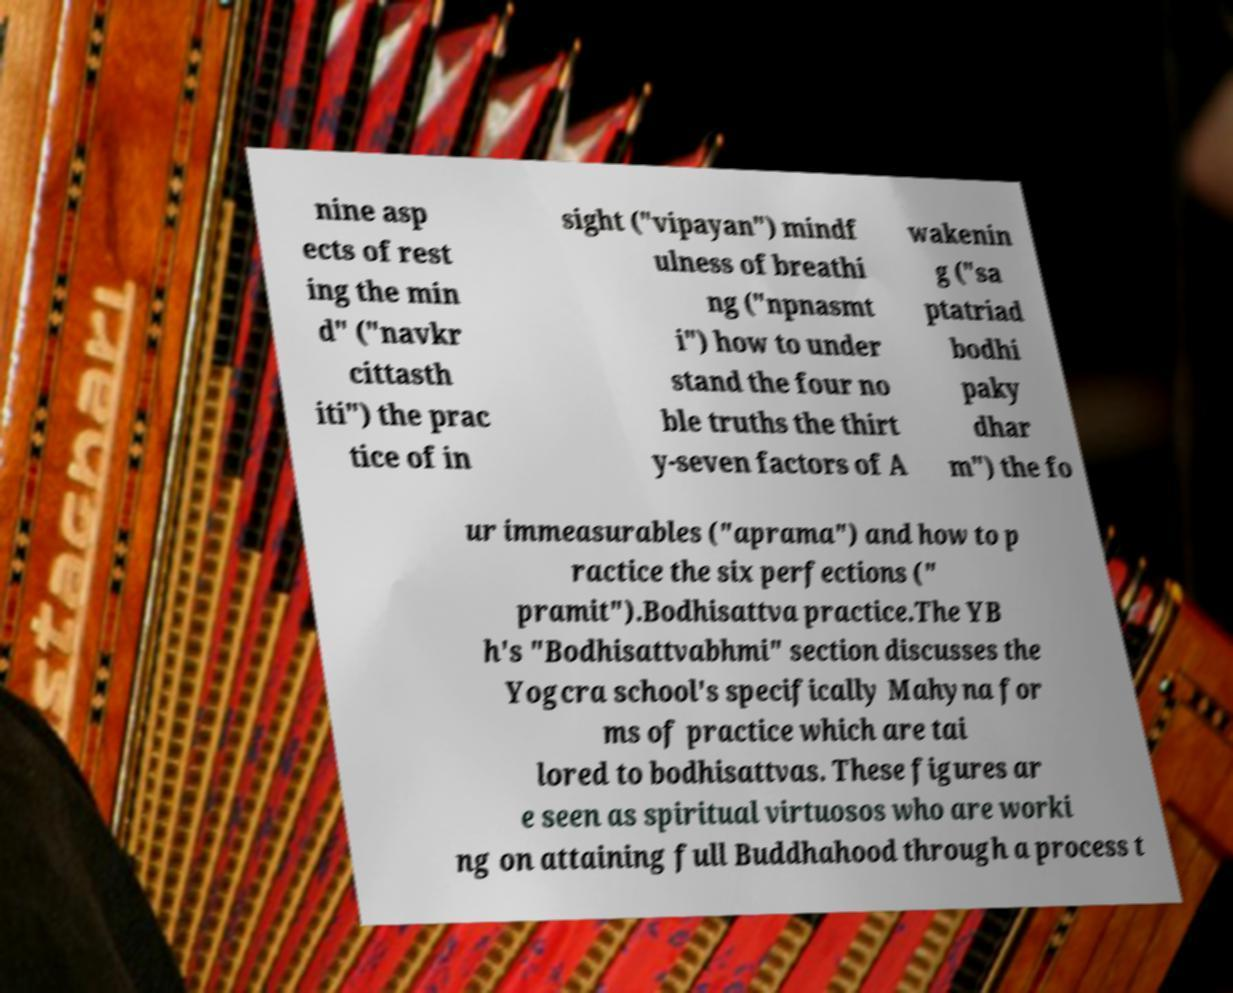Please read and relay the text visible in this image. What does it say? nine asp ects of rest ing the min d" ("navkr cittasth iti") the prac tice of in sight ("vipayan") mindf ulness of breathi ng ("npnasmt i") how to under stand the four no ble truths the thirt y-seven factors of A wakenin g ("sa ptatriad bodhi paky dhar m") the fo ur immeasurables ("aprama") and how to p ractice the six perfections (" pramit").Bodhisattva practice.The YB h's "Bodhisattvabhmi" section discusses the Yogcra school's specifically Mahyna for ms of practice which are tai lored to bodhisattvas. These figures ar e seen as spiritual virtuosos who are worki ng on attaining full Buddhahood through a process t 